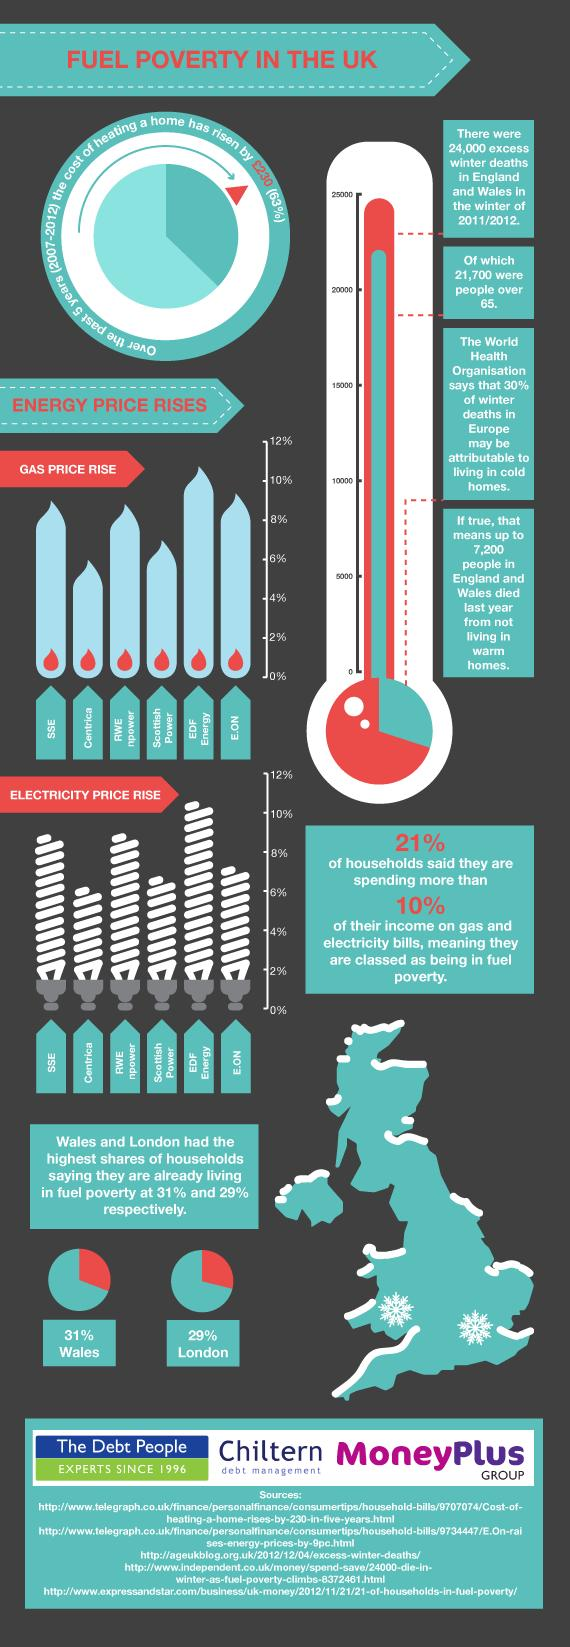Mention a couple of crucial points in this snapshot. Centrica has the lowest percentage of electricity price rise among all companies. The percentage increase in gas prices for Scottish Power is 7%. EDF Energy has the highest percentage of electricity price rise among all companies. According to recent reports, approximately 2300 people have died below the age of 65. The infographic contains six electric bulbs. 